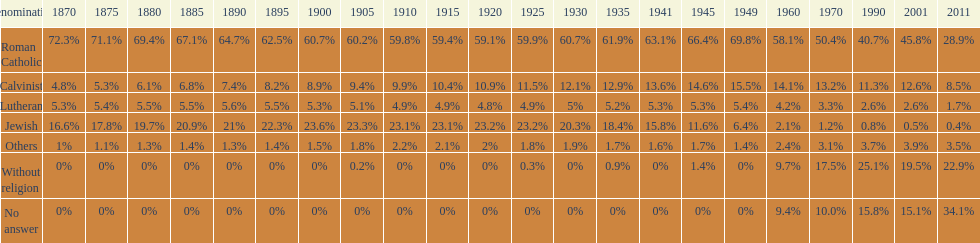Which denomination percentage increased the most after 1949? Without religion. 